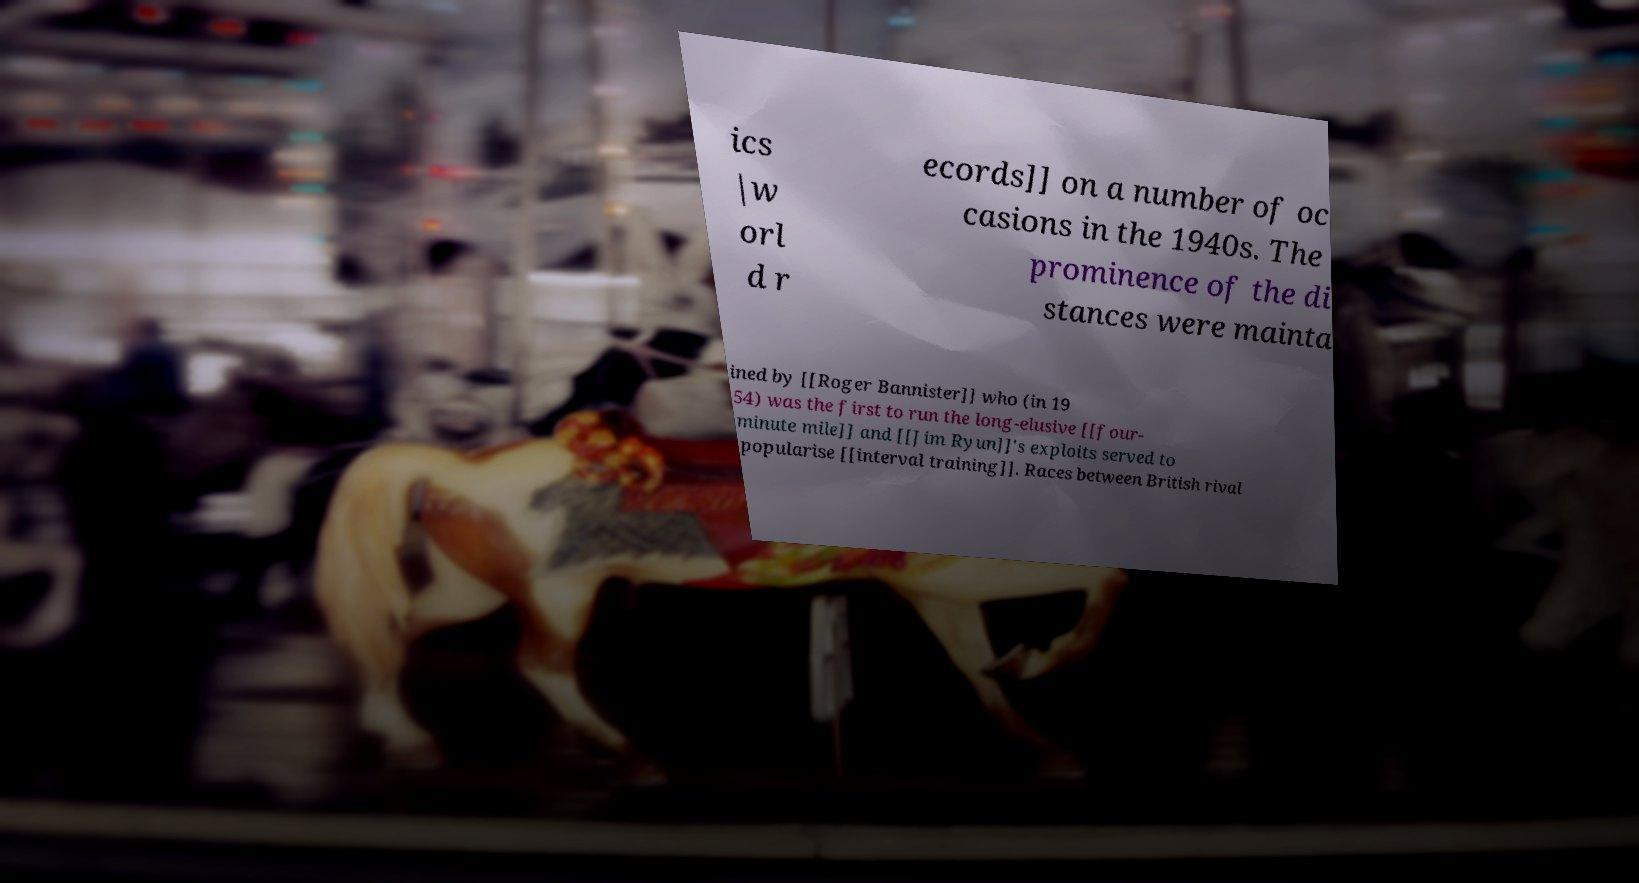For documentation purposes, I need the text within this image transcribed. Could you provide that? ics |w orl d r ecords]] on a number of oc casions in the 1940s. The prominence of the di stances were mainta ined by [[Roger Bannister]] who (in 19 54) was the first to run the long-elusive [[four- minute mile]] and [[Jim Ryun]]'s exploits served to popularise [[interval training]]. Races between British rival 